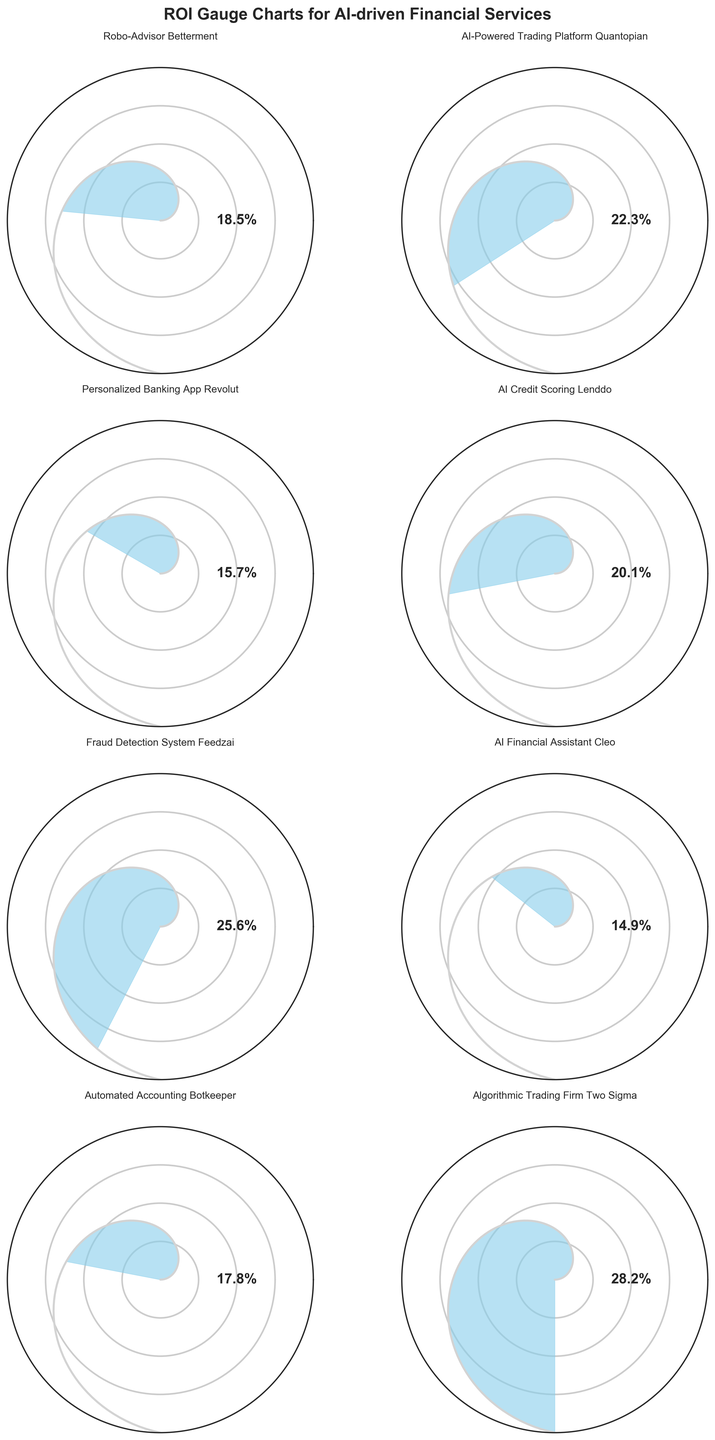What's the title of the figure? The title is usually located at the top of the figure and summarizes the content visually displayed. In this case, it will likely include terms related to ROI and gauge charts for AI-driven financial services.
Answer: ROI Gauge Charts for AI-driven Financial Services How many companies are included in the figure? The figure is organized into subplots for different companies. By counting these subplots, you can determine the number of companies. In this case, there are 8 subplots.
Answer: 8 What is the ROI for the company Two Sigma? Locate the subplot labeled "Two Sigma" and read the ROI value displayed within the gauge chart.
Answer: 28.2% Which company has the lowest ROI and what is the value? Identify the subplot with the smallest ROI value and its corresponding company name. In this case, it's "AI Financial Assistant Cleo" with the ROI value of 14.9%.
Answer: AI Financial Assistant Cleo, 14.9% What's the average ROI for all the companies? Add together the ROI values of all companies and divide by the number of companies. For example, (18.5 + 22.3 + 15.7 + 20.1 + 25.6 + 14.9 + 17.8 + 28.2) / 8 = 20.39%
Answer: 20.39% Which company has the highest ROI and what is the value? Locate the subplot with the highest ROI value and note its corresponding company name and value. Here, it is "Algorithmic Trading Firm Two Sigma" with an ROI of 28.2%.
Answer: Algorithmic Trading Firm Two Sigma, 28.2% How does the ROI of Quantopian compare with that of Feedzai? Subtract the ROI of Quantopian from Feedzai. Feedzai's ROI is 25.6% and Quantopian's is 22.3%. The difference is 25.6% - 22.3%.
Answer: Feedzai is higher by 3.3% Which two companies are closest in ROI values? Compare the absolute differences between all pairs; the smallest difference is between Betterment (18.5%) and Botkeeper (17.8%). The difference is 0.7%.
Answer: Robo-Advisor Betterment and Automated Accounting Botkeeper Which company's ROI falls below the average ROI of all companies? Calculate the average ROI first (20.39%), then identify companies with ROI below 20.39%. These companies are Personalized Banking App Revolut (15.7%), AI Financial Assistant Cleo (14.9%), and Automated Accounting Botkeeper (17.8%).
Answer: Personalized Banking App Revolut, AI Financial Assistant Cleo, Automated Accounting Botkeeper 